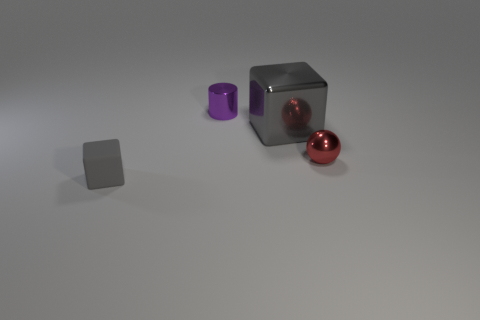Are there any other things that are the same size as the gray shiny object?
Your response must be concise. No. There is another object that is the same color as the small matte thing; what is its size?
Keep it short and to the point. Large. What shape is the large object that is the same color as the tiny rubber cube?
Your answer should be compact. Cube. What number of red things are the same size as the purple metal thing?
Provide a succinct answer. 1. There is a metal thing that is both to the right of the purple object and behind the small red object; what is its color?
Your answer should be very brief. Gray. How many objects are big shiny objects or red balls?
Provide a succinct answer. 2. What number of big objects are yellow metallic cubes or metal blocks?
Give a very brief answer. 1. Are there any other things that have the same color as the metallic sphere?
Make the answer very short. No. There is a metallic thing that is behind the red metal object and right of the purple cylinder; how big is it?
Give a very brief answer. Large. Do the block that is to the left of the large gray thing and the cube behind the ball have the same color?
Offer a very short reply. Yes. 